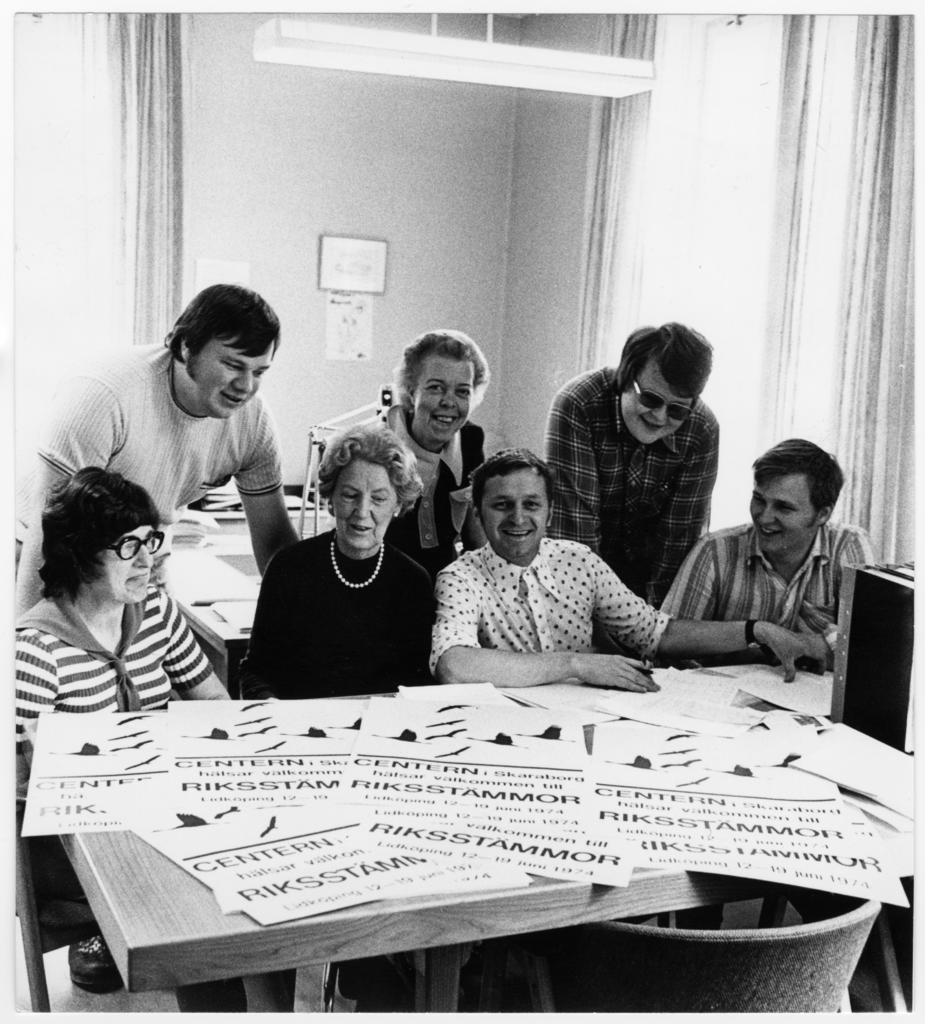How many people are in the image? There is a group of persons in the image. What are the persons doing in the image? The persons are sitting on chairs and looking at boards. Can you describe the lighting in the image? There is a light in the image. What else can be seen related to electricity in the image? There is a switch board in the image. What is the daughter saying about the statement on the scale in the image? There is no daughter, statement, or scale present in the image. 